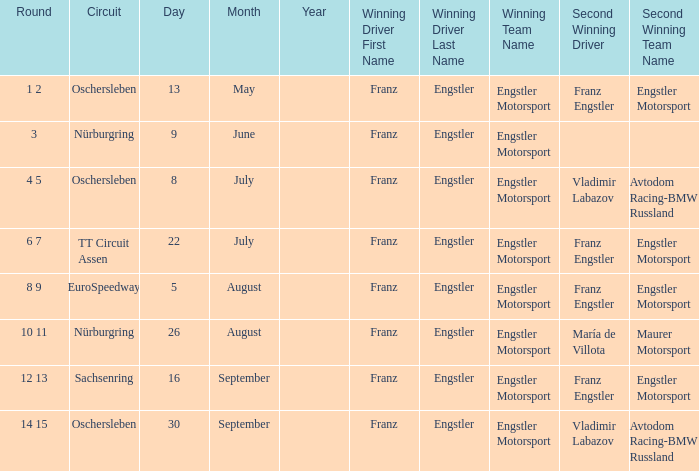What Winning team has 22 July as a Date? Engstler Motorsport Engstler Motorsport. 